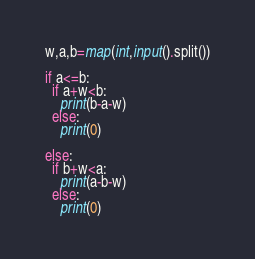<code> <loc_0><loc_0><loc_500><loc_500><_Python_>w,a,b=map(int,input().split())

if a<=b:
  if a+w<b:
    print(b-a-w)
  else:
    print(0)
    
else:
  if b+w<a:
    print(a-b-w)
  else:
    print(0)</code> 